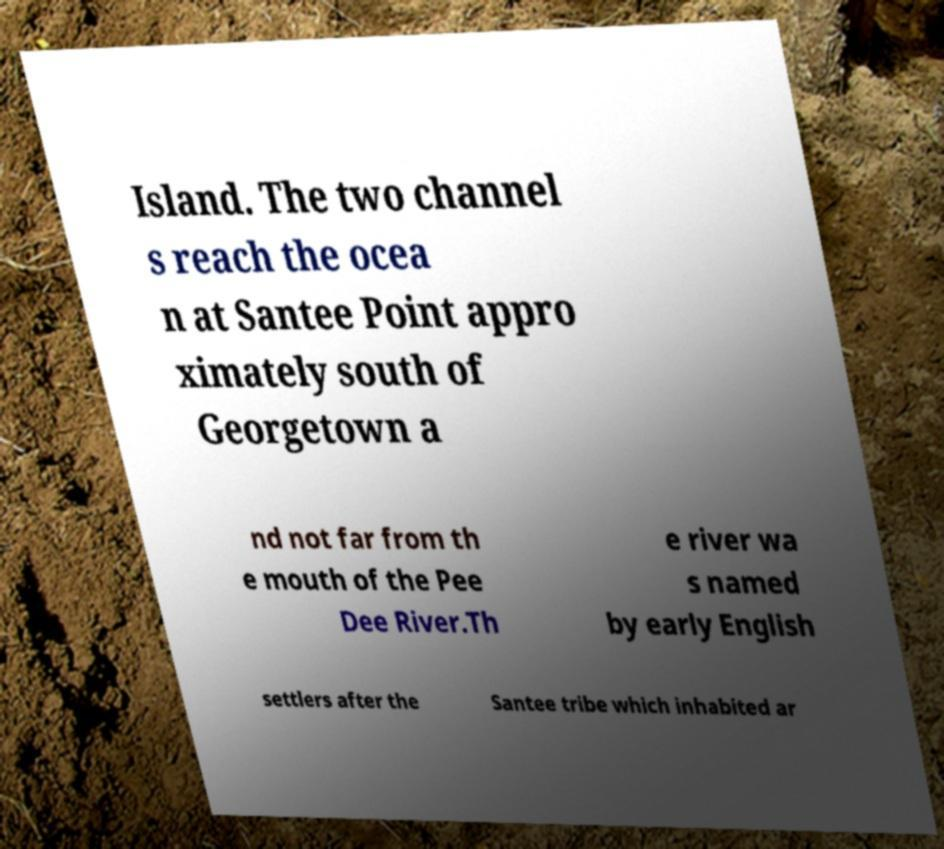Please read and relay the text visible in this image. What does it say? Island. The two channel s reach the ocea n at Santee Point appro ximately south of Georgetown a nd not far from th e mouth of the Pee Dee River.Th e river wa s named by early English settlers after the Santee tribe which inhabited ar 